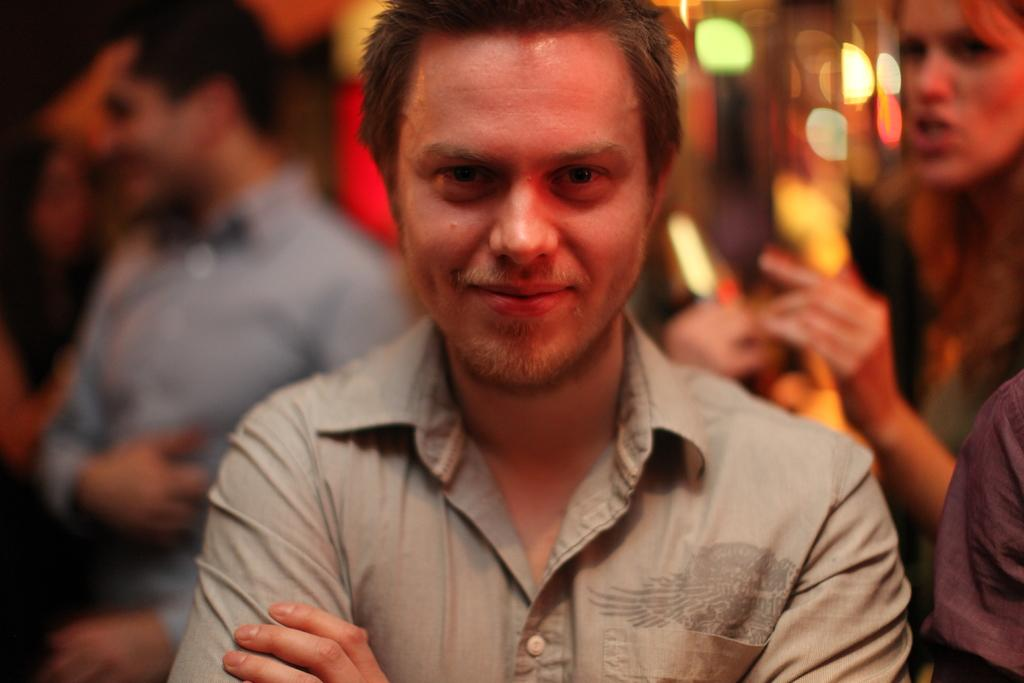What is the facial expression of the person in the image? The person in the image has a smile on their face. Are there any other people visible in the image? Yes, there are other people standing behind the person in the image. How would you describe the background of the image? The background of the image is blurred. What type of garden can be seen in the background of the image? There is no garden visible in the background of the image; it is blurred. How many eggs are present on the chair in the image? There is no chair or eggs present in the image. 